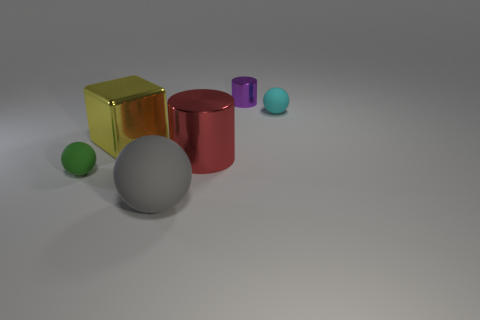Are there any purple metallic things of the same shape as the large yellow shiny thing?
Keep it short and to the point. No. What color is the other shiny thing that is the same size as the red shiny thing?
Give a very brief answer. Yellow. What is the color of the small rubber object that is behind the tiny matte object that is in front of the cyan object?
Provide a short and direct response. Cyan. There is a tiny matte ball that is in front of the cyan matte sphere; is it the same color as the large metallic block?
Offer a terse response. No. What shape is the object in front of the small rubber object in front of the tiny matte object that is to the right of the large gray thing?
Offer a terse response. Sphere. There is a tiny thing that is to the left of the small purple metallic cylinder; how many tiny rubber spheres are behind it?
Your answer should be very brief. 1. Do the large gray ball and the large yellow thing have the same material?
Offer a terse response. No. There is a matte thing that is in front of the sphere that is to the left of the big matte ball; what number of balls are behind it?
Keep it short and to the point. 2. What is the color of the tiny rubber object in front of the red cylinder?
Provide a succinct answer. Green. There is a object that is behind the small matte sphere that is to the right of the small purple metallic cylinder; what is its shape?
Your answer should be compact. Cylinder. 